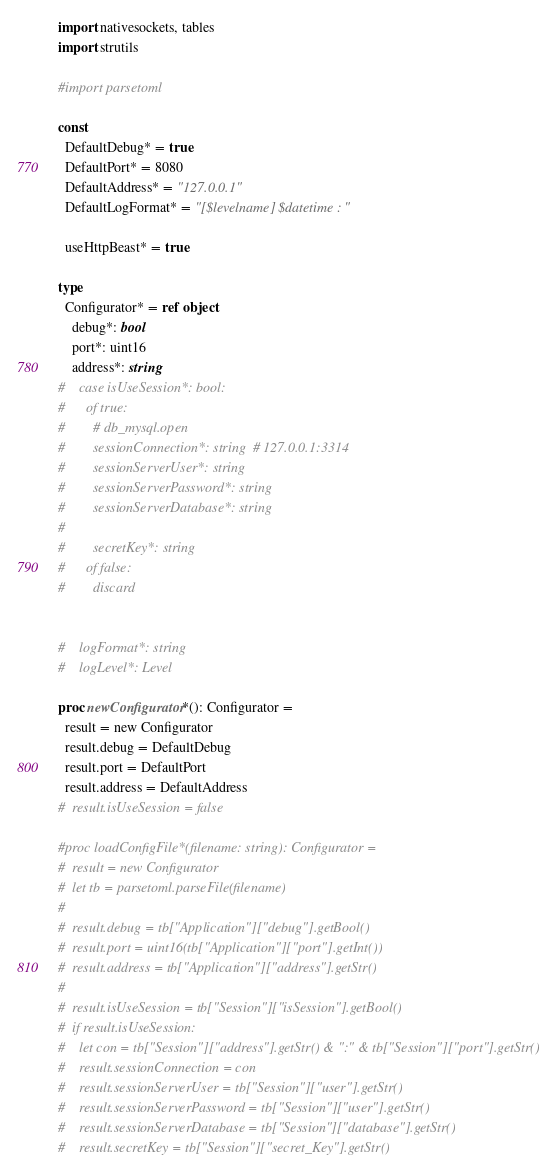Convert code to text. <code><loc_0><loc_0><loc_500><loc_500><_Nim_>import nativesockets, tables
import strutils

#import parsetoml

const
  DefaultDebug* = true
  DefaultPort* = 8080
  DefaultAddress* = "127.0.0.1"
  DefaultLogFormat* = "[$levelname] $datetime : "

  useHttpBeast* = true

type
  Configurator* = ref object
    debug*: bool
    port*: uint16
    address*: string
#    case isUseSession*: bool:
#      of true:
#        # db_mysql.open
#        sessionConnection*: string  # 127.0.0.1:3314
#        sessionServerUser*: string
#        sessionServerPassword*: string
#        sessionServerDatabase*: string
#
#        secretKey*: string
#      of false:
#        discard


#    logFormat*: string
#    logLevel*: Level

proc newConfigurator*(): Configurator =
  result = new Configurator
  result.debug = DefaultDebug
  result.port = DefaultPort
  result.address = DefaultAddress
#  result.isUseSession = false

#proc loadConfigFile*(filename: string): Configurator =
#  result = new Configurator
#  let tb = parsetoml.parseFile(filename)
#  
#  result.debug = tb["Application"]["debug"].getBool()
#  result.port = uint16(tb["Application"]["port"].getInt())
#  result.address = tb["Application"]["address"].getStr()
#  
#  result.isUseSession = tb["Session"]["isSession"].getBool()
#  if result.isUseSession:
#    let con = tb["Session"]["address"].getStr() & ":" & tb["Session"]["port"].getStr()
#    result.sessionConnection = con
#    result.sessionServerUser = tb["Session"]["user"].getStr()
#    result.sessionServerPassword = tb["Session"]["user"].getStr()
#    result.sessionServerDatabase = tb["Session"]["database"].getStr()
#    result.secretKey = tb["Session"]["secret_Key"].getStr()
</code> 